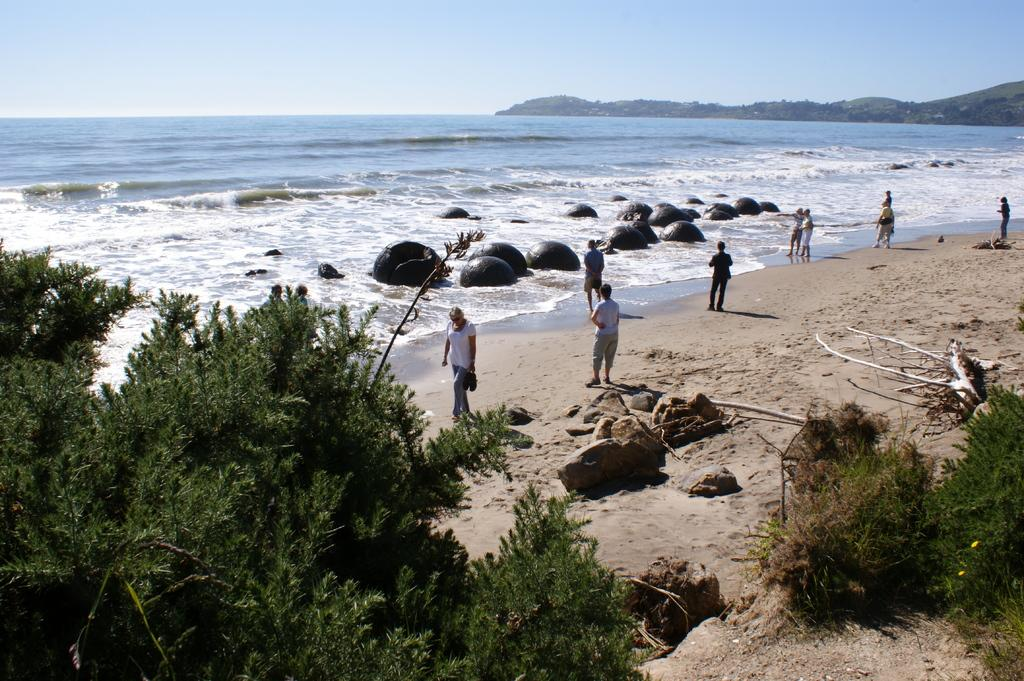What is the main feature of the image? The main feature of the image is water. What else can be seen in the image besides water? There are rocks, people standing, people walking, trees, and a blue and cloudy sky in the image. What are the people in the image doing? The people in the image are standing and walking. What type of vegetation is present in the image? Trees are present in the image. Where is the gold station located in the image? There is no gold station present in the image. What type of team can be seen playing in the image? There is no team or any sports activity depicted in the image. 